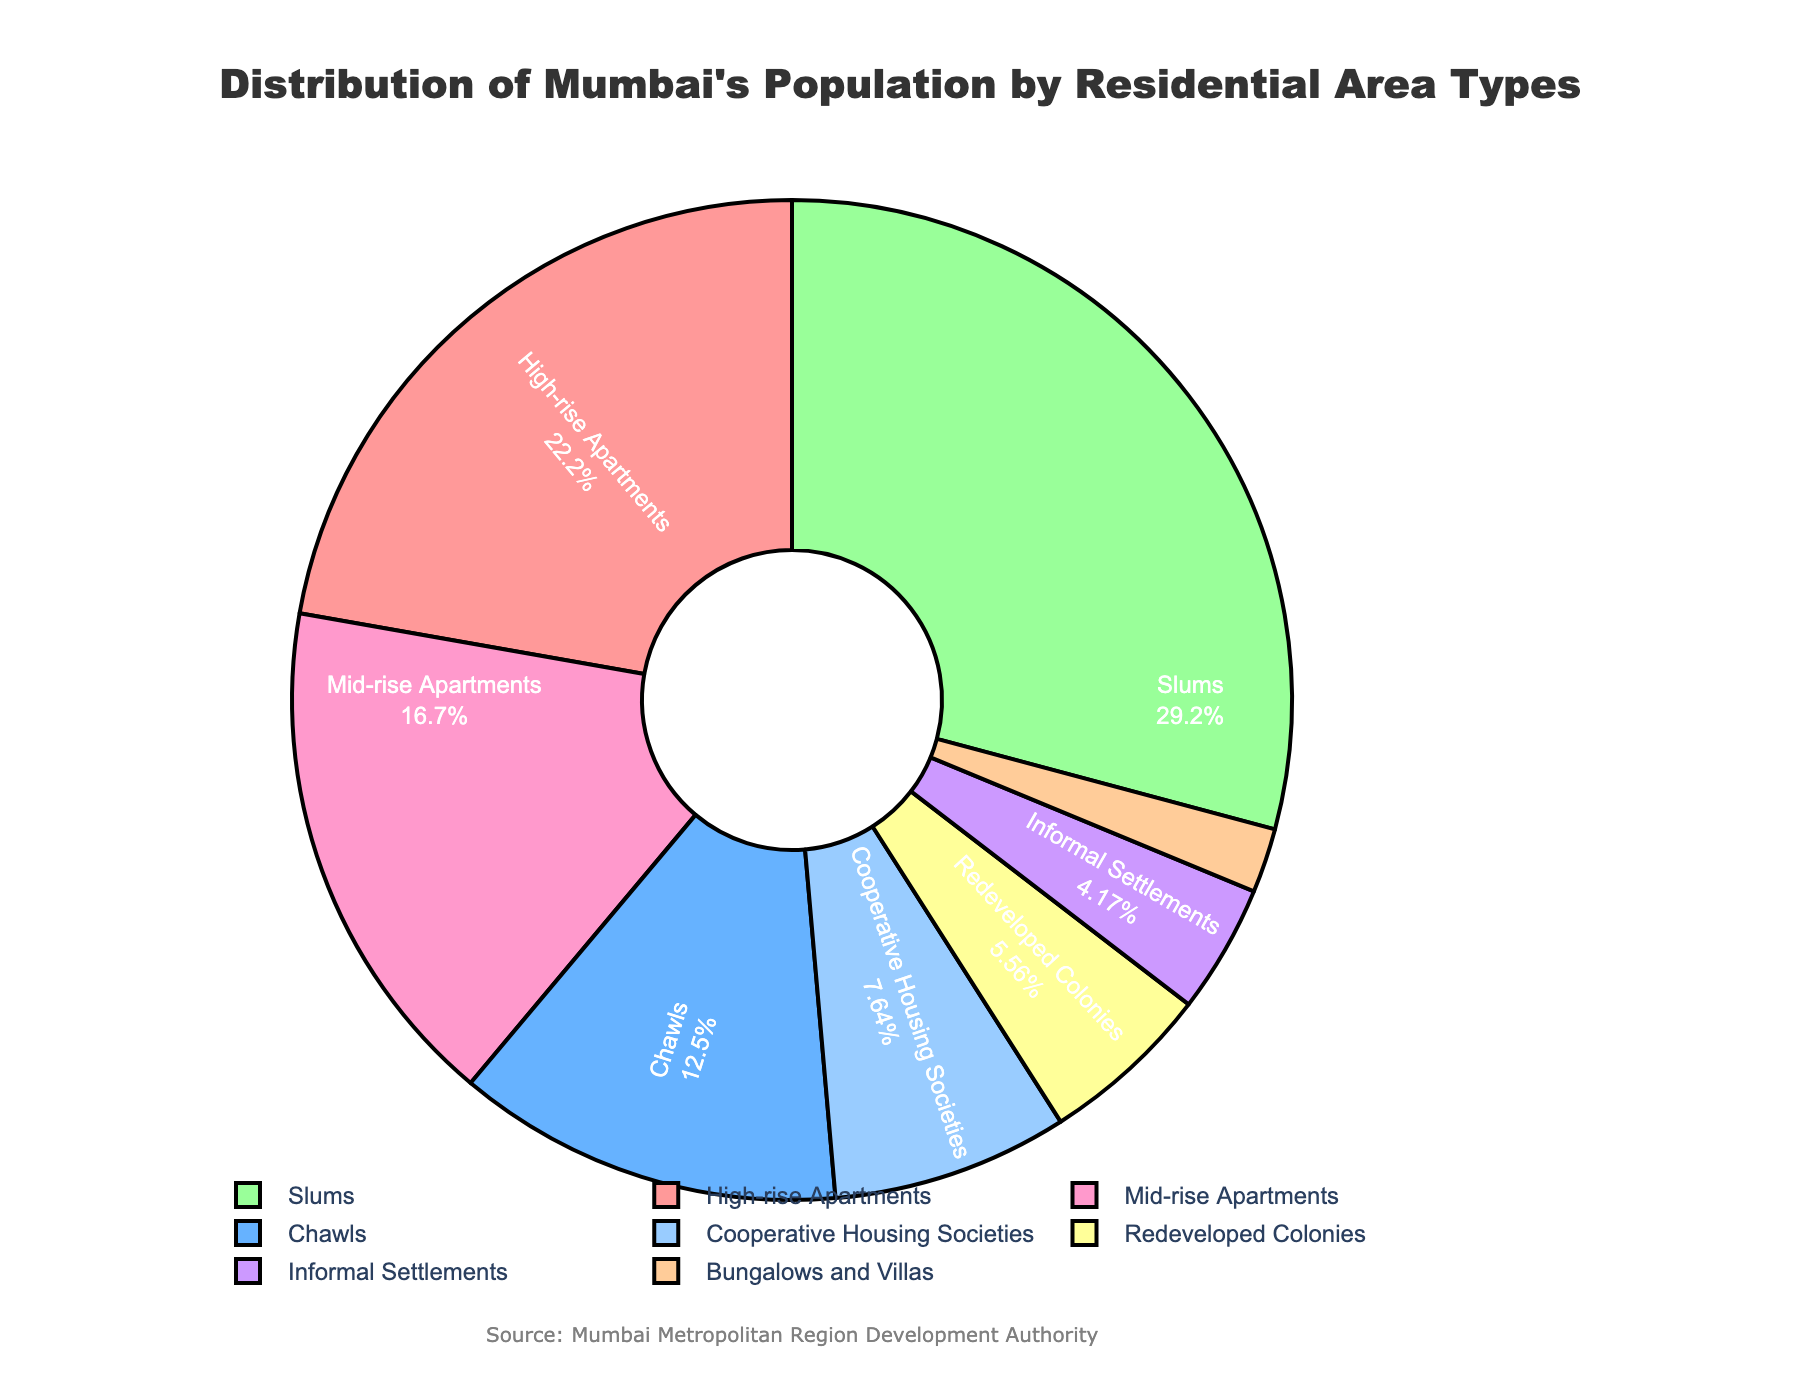what percentage of Mumbai’s population lives in high-rise apartments? To determine this, look at the slice of the pie corresponding to 'High-rise Apartments'. The percentage is indicated directly on the slice.
Answer: 32% Which area type has the highest population percentage? Identify the largest slice on the pie chart. The label on this slice indicates the area type with the highest population percentage.
Answer: Slums How does the percentage of people living in mid-rise apartments compare to those in cooperative housing societies? Identify the percentages for 'Mid-rise Apartments' and 'Cooperative Housing Societies' from their respective pie slices. Compare these values.
Answer: Mid-rise Apartments: 24%, Cooperative Housing Societies: 11%. Mid-rise Apartments have a higher percentage What is the combined population percentage of people living in bungalows/villas and redeveloped colonies? Add the population percentages for 'Bungalows and Villas' (3%) and 'Redeveloped Colonies' (8%).
Answer: 11% What’s the difference in population percentage between slums and chawls? Subtract the population percentage of 'Chawls' (18%) from 'Slums' (42%).
Answer: 24% Which two area types have the closest population percentages? Carefully examine the pie slices and list the percentages for all area types. Identify the two area types with the smallest difference in population percentages.
Answer: Cooperative Housing Societies (11%) and Redeveloped Colonies (8%) What color represents the areas where the least and the most people live? Identify the colors corresponding to the smallest and largest pie slices, which represent 'Bungalows and Villas' for the least and 'Slums' for the most populated areas.
Answer: Least: Red, Most: Blue Comparing the percentages of people living in informal settlements and redeveloped colonies, which area type has a higher population percentage? Check the values directly on the pie chart. Compare 'Informal Settlements' (6%) with 'Redeveloped Colonies' (8%).
Answer: Redeveloped Colonies have a higher percentage 